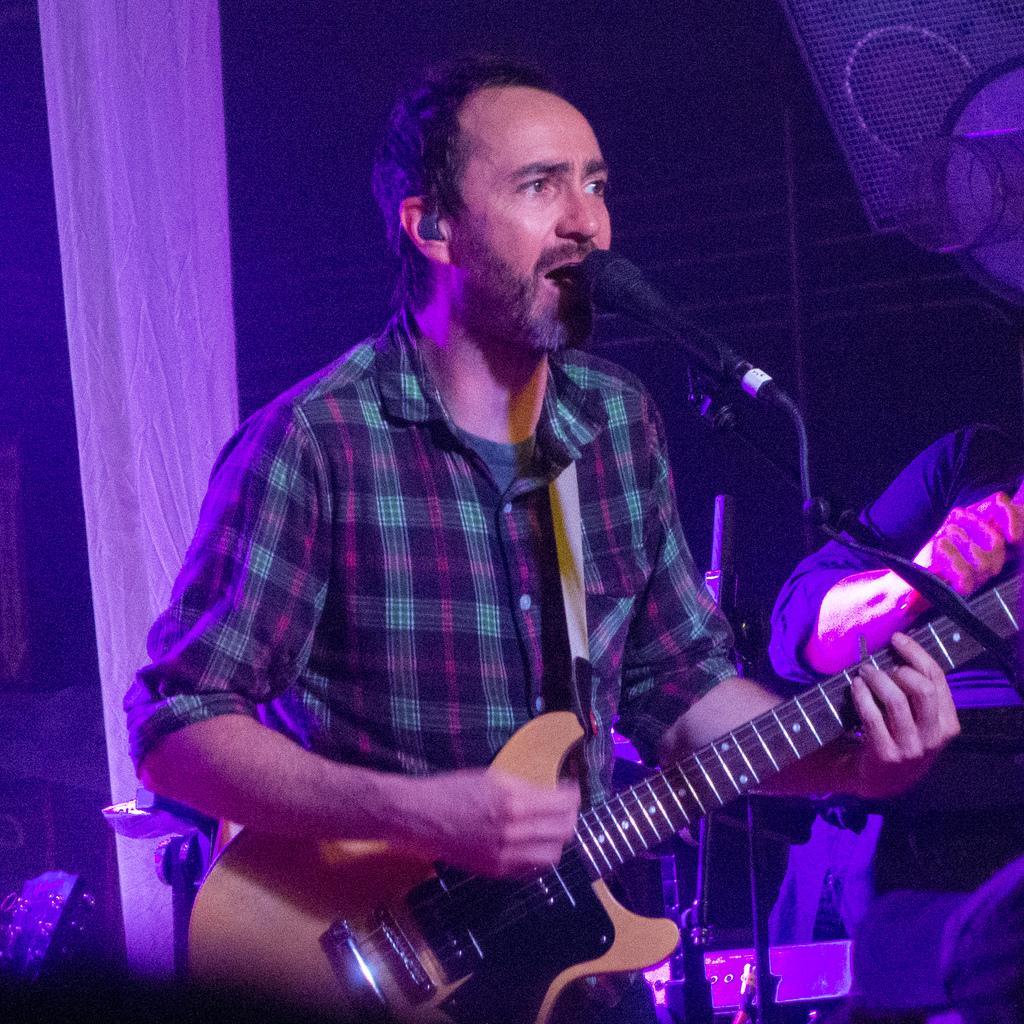Please provide a concise description of this image. this picture shows a man standing and playing a guitar and singing with the help of a microphone 